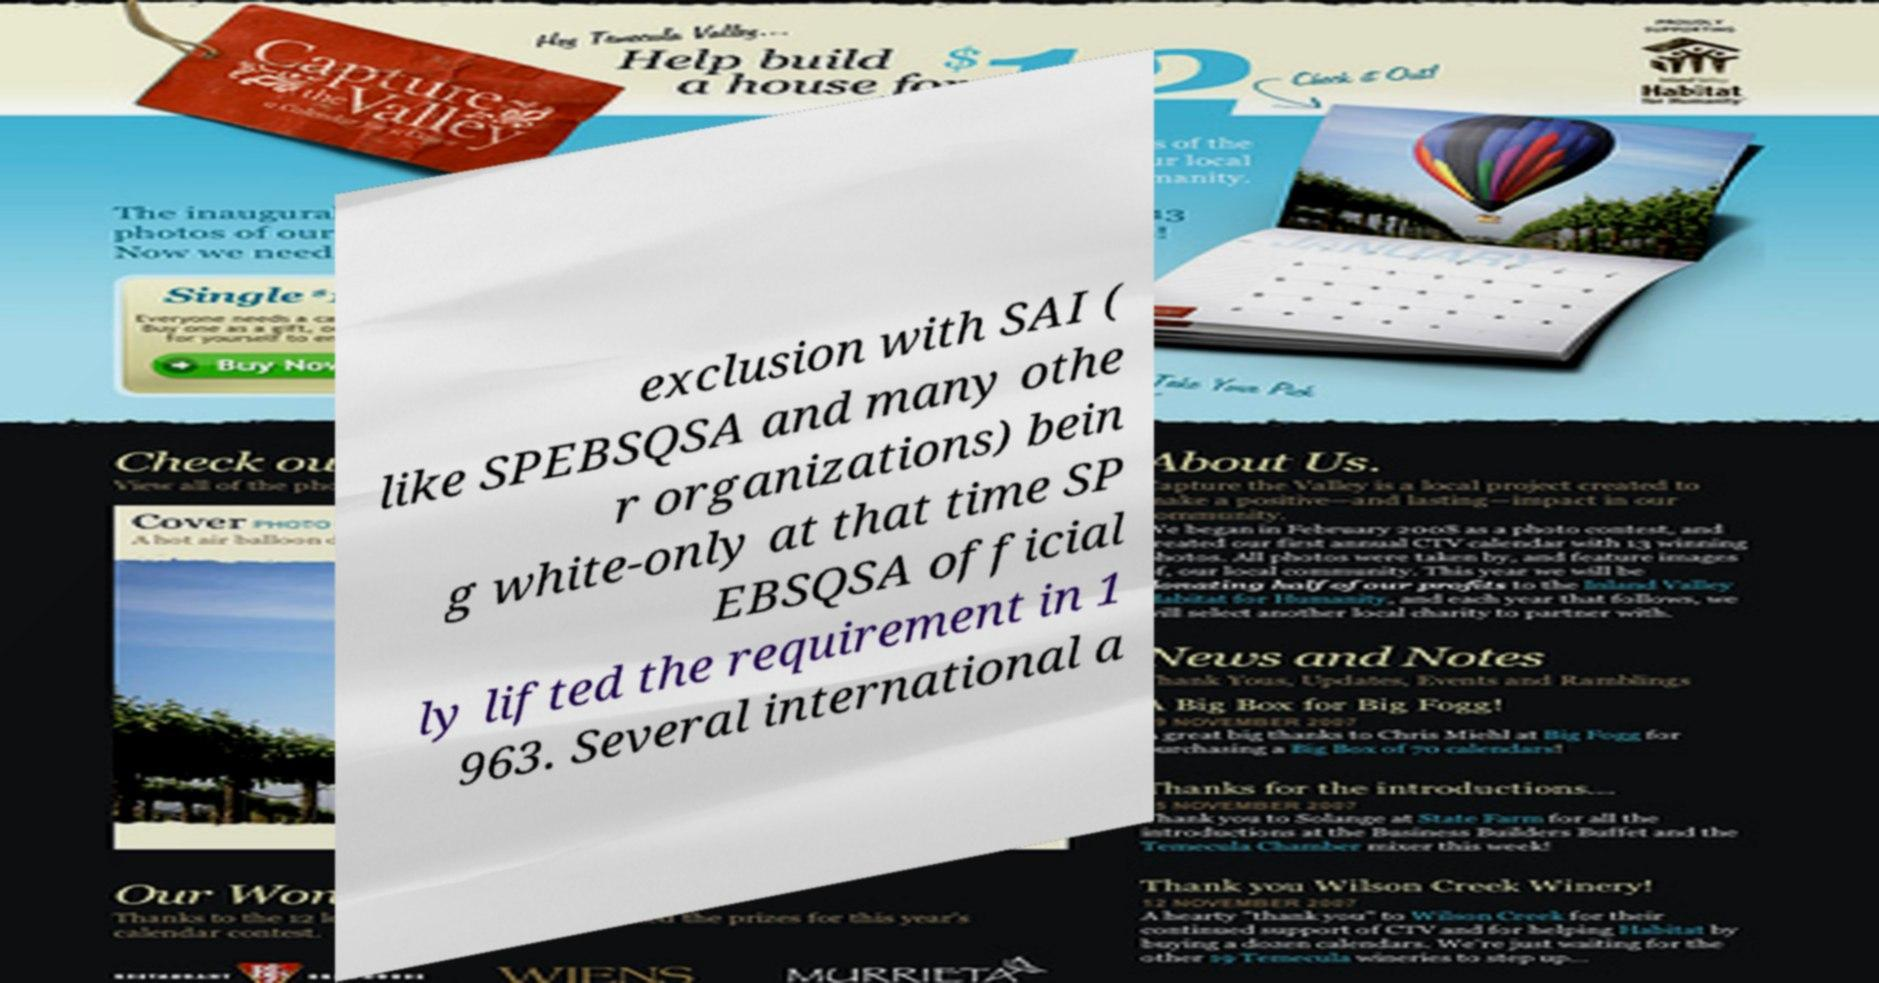There's text embedded in this image that I need extracted. Can you transcribe it verbatim? exclusion with SAI ( like SPEBSQSA and many othe r organizations) bein g white-only at that time SP EBSQSA official ly lifted the requirement in 1 963. Several international a 